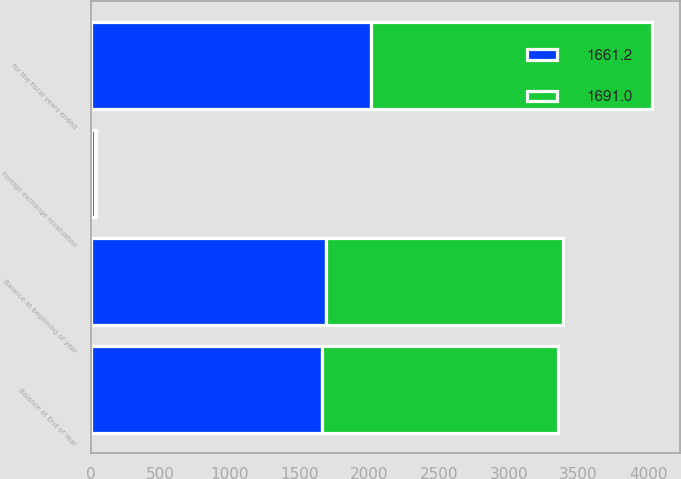Convert chart to OTSL. <chart><loc_0><loc_0><loc_500><loc_500><stacked_bar_chart><ecel><fcel>for the fiscal years ended<fcel>Balance at beginning of year<fcel>Foreign exchange revaluation<fcel>Balance at End of Year<nl><fcel>1661.2<fcel>2015<fcel>1691<fcel>29.8<fcel>1661.2<nl><fcel>1691<fcel>2014<fcel>1701.5<fcel>10.5<fcel>1691<nl></chart> 